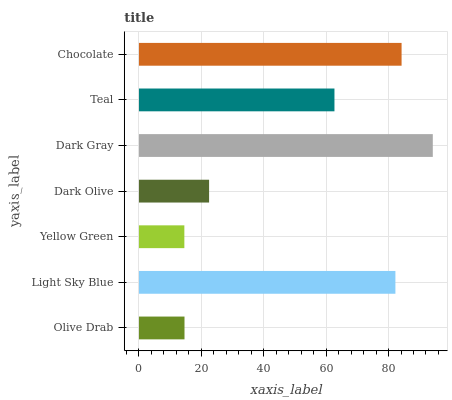Is Yellow Green the minimum?
Answer yes or no. Yes. Is Dark Gray the maximum?
Answer yes or no. Yes. Is Light Sky Blue the minimum?
Answer yes or no. No. Is Light Sky Blue the maximum?
Answer yes or no. No. Is Light Sky Blue greater than Olive Drab?
Answer yes or no. Yes. Is Olive Drab less than Light Sky Blue?
Answer yes or no. Yes. Is Olive Drab greater than Light Sky Blue?
Answer yes or no. No. Is Light Sky Blue less than Olive Drab?
Answer yes or no. No. Is Teal the high median?
Answer yes or no. Yes. Is Teal the low median?
Answer yes or no. Yes. Is Dark Gray the high median?
Answer yes or no. No. Is Light Sky Blue the low median?
Answer yes or no. No. 